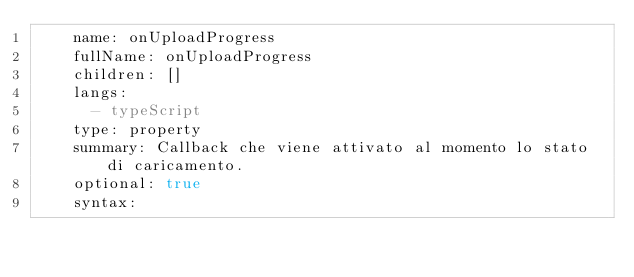<code> <loc_0><loc_0><loc_500><loc_500><_YAML_>    name: onUploadProgress
    fullName: onUploadProgress
    children: []
    langs:
      - typeScript
    type: property
    summary: Callback che viene attivato al momento lo stato di caricamento.
    optional: true
    syntax:</code> 